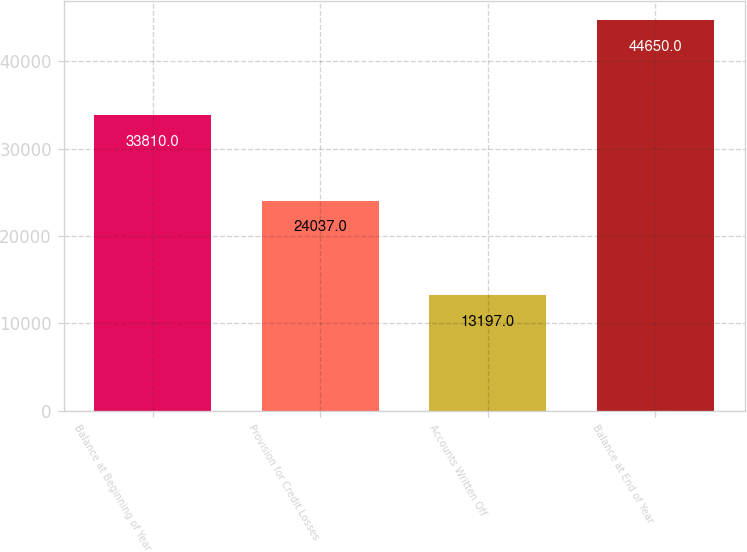Convert chart to OTSL. <chart><loc_0><loc_0><loc_500><loc_500><bar_chart><fcel>Balance at Beginning of Year<fcel>Provision for Credit Losses<fcel>Accounts Written Off<fcel>Balance at End of Year<nl><fcel>33810<fcel>24037<fcel>13197<fcel>44650<nl></chart> 